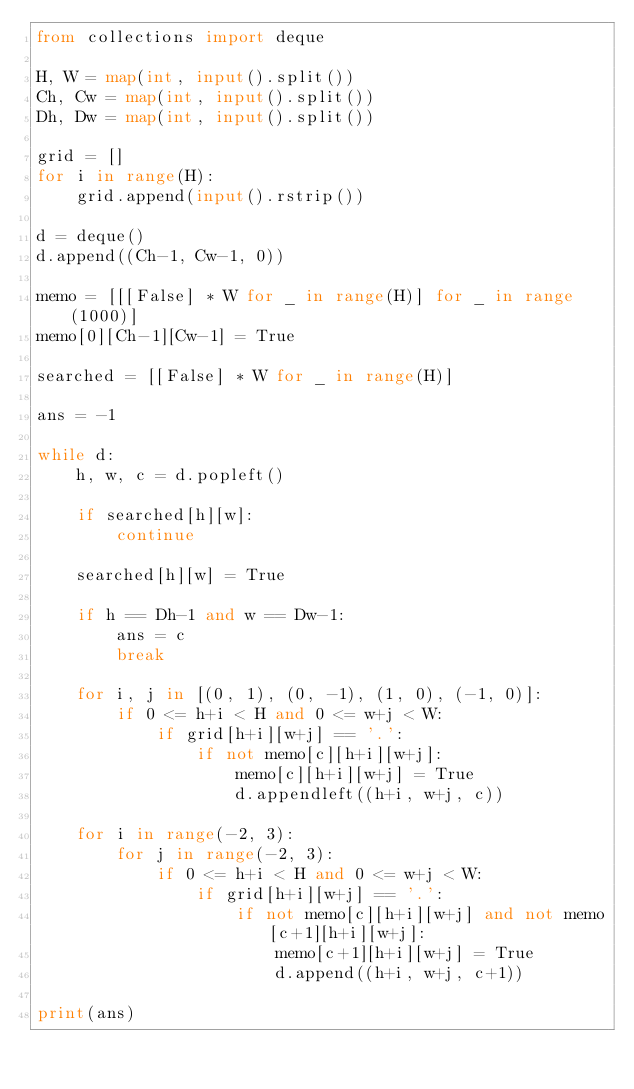Convert code to text. <code><loc_0><loc_0><loc_500><loc_500><_Python_>from collections import deque

H, W = map(int, input().split())
Ch, Cw = map(int, input().split())
Dh, Dw = map(int, input().split())

grid = []
for i in range(H):
    grid.append(input().rstrip())

d = deque()
d.append((Ch-1, Cw-1, 0))

memo = [[[False] * W for _ in range(H)] for _ in range(1000)]
memo[0][Ch-1][Cw-1] = True

searched = [[False] * W for _ in range(H)]

ans = -1

while d:
    h, w, c = d.popleft()

    if searched[h][w]:
        continue

    searched[h][w] = True

    if h == Dh-1 and w == Dw-1:
        ans = c
        break

    for i, j in [(0, 1), (0, -1), (1, 0), (-1, 0)]:
        if 0 <= h+i < H and 0 <= w+j < W:
            if grid[h+i][w+j] == '.':
                if not memo[c][h+i][w+j]:
                    memo[c][h+i][w+j] = True
                    d.appendleft((h+i, w+j, c))

    for i in range(-2, 3):
        for j in range(-2, 3):
            if 0 <= h+i < H and 0 <= w+j < W:
                if grid[h+i][w+j] == '.':
                    if not memo[c][h+i][w+j] and not memo[c+1][h+i][w+j]:
                        memo[c+1][h+i][w+j] = True
                        d.append((h+i, w+j, c+1))

print(ans)
</code> 